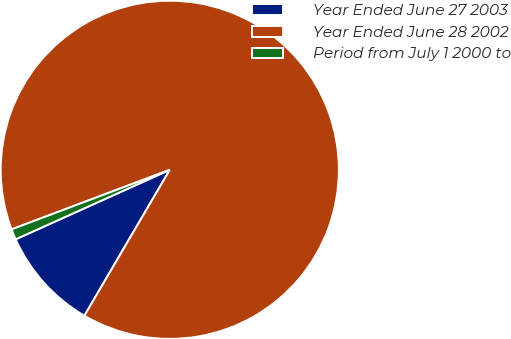Convert chart. <chart><loc_0><loc_0><loc_500><loc_500><pie_chart><fcel>Year Ended June 27 2003<fcel>Year Ended June 28 2002<fcel>Period from July 1 2000 to<nl><fcel>9.83%<fcel>89.16%<fcel>1.01%<nl></chart> 